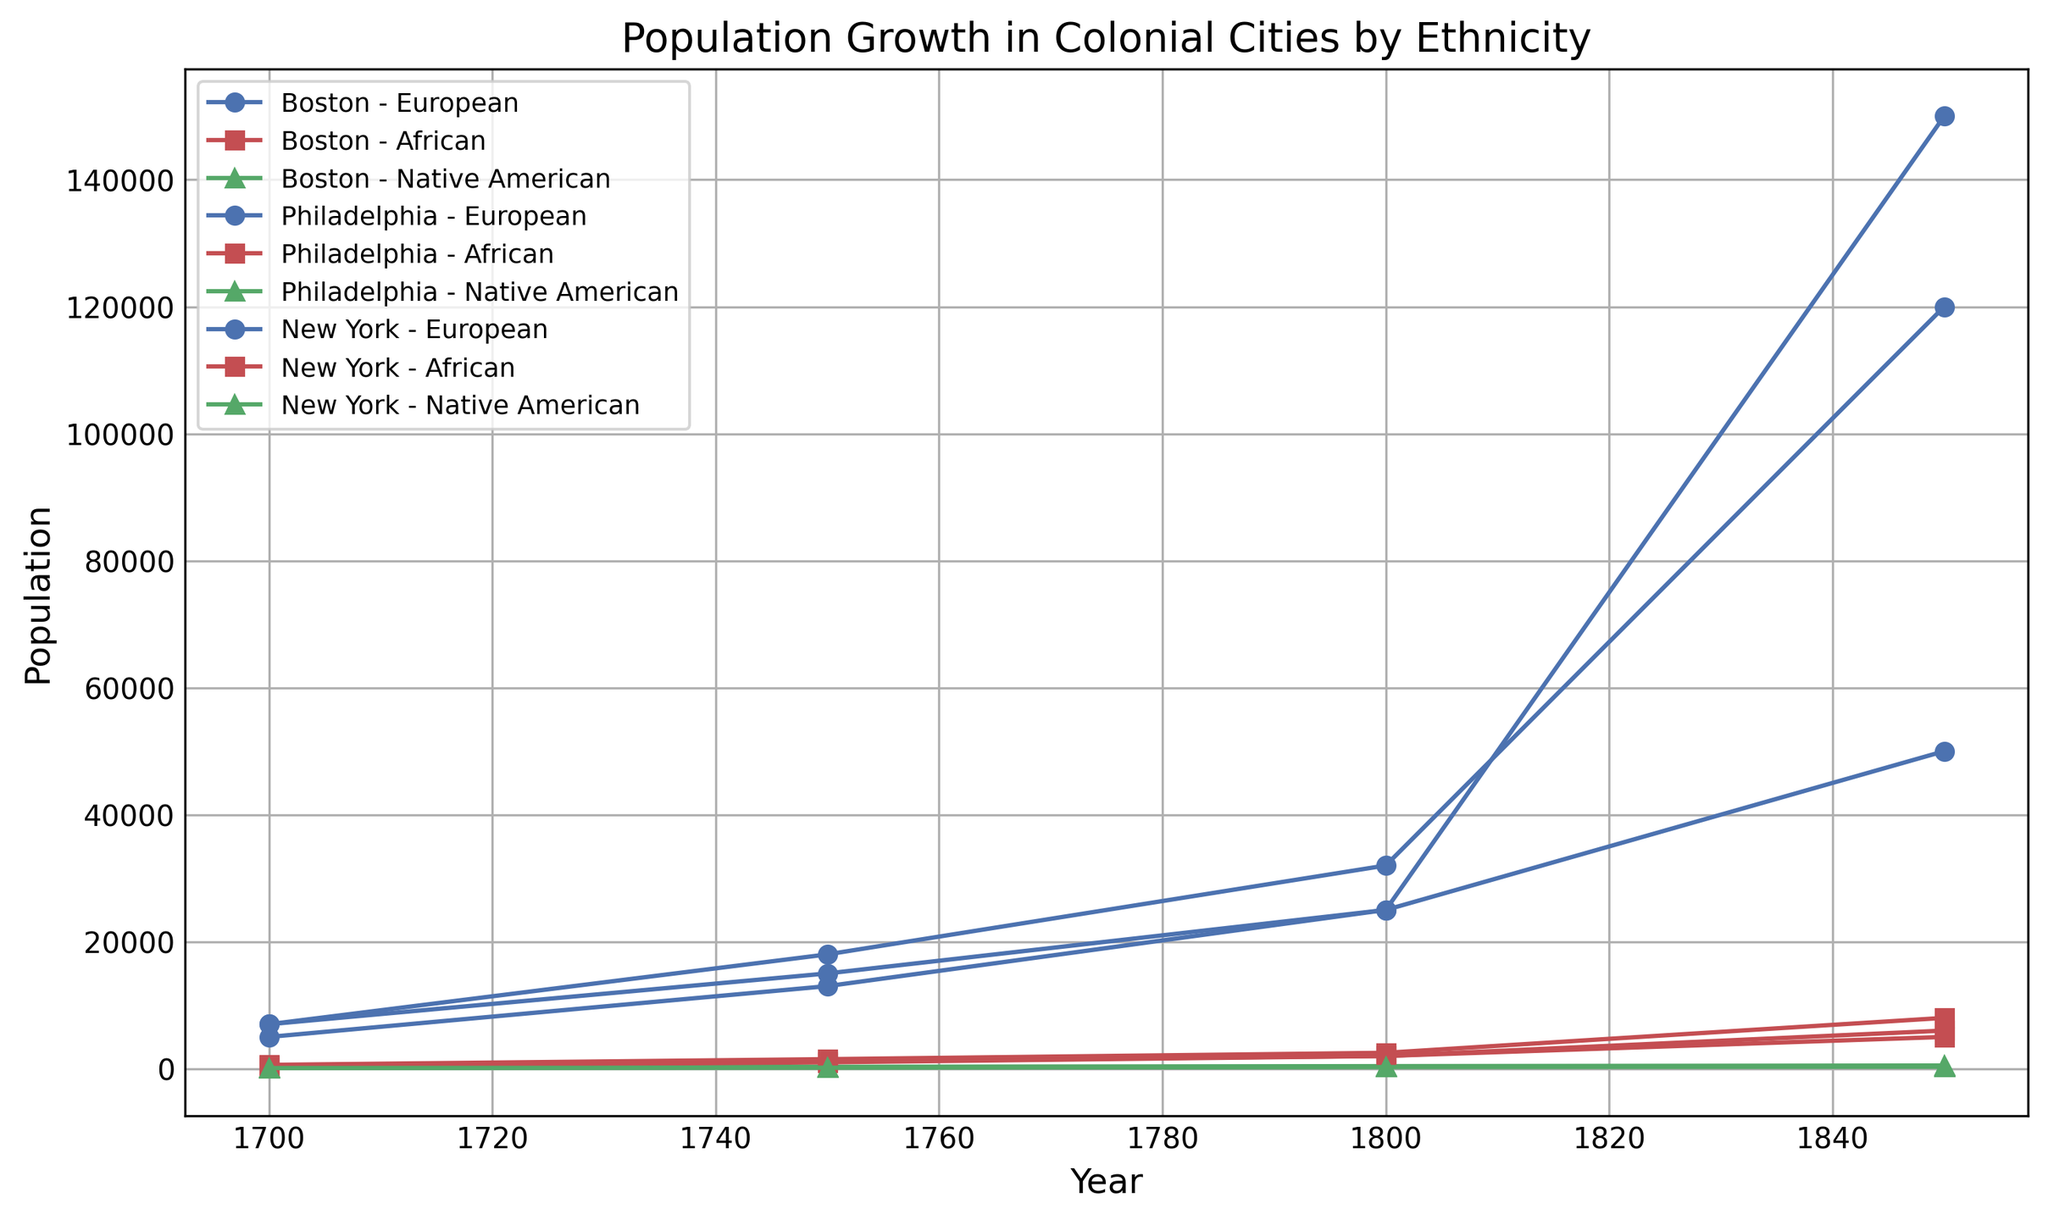What is the population difference between Europeans and Africans in Boston in 1850? From the chart, locate the population of Europeans and Africans in Boston in 1850, which are 50,000 and 5,000 respectively. The difference is obtained by subtracting the African population from the European population: 50,000 - 5,000 = 45,000.
Answer: 45,000 Which city had the largest population of Native Americans in 1750? From the figure, compare the populations of Native Americans in Boston, Philadelphia, and New York in 1750. The populations are 300, 200, and 150 respectively. Philadelphia had the largest population of Native Americans in 1750.
Answer: Philadelphia How did the European population in New York change between 1700 and 1850? Locate the European population in New York at 1700 and 1850, which are 5,000 and 150,000 respectively. The change is calculated by subtracting the 1700 value from the 1850 value: 150,000 - 5,000 = 145,000.
Answer: 145,000 Between 1700 and 1850, which city saw the greatest increase in the African population? For each city, calculate the increase in the African population from 1700 to 1850: Boston (5000 - 500 = 4500), Philadelphia (8000 - 600 = 7400), New York (6000 - 400 = 5600). Philadelphia had the greatest increase.
Answer: Philadelphia What is the average Native American population of New York from 1700 to 1850? The Native American populations of New York in the years 1700, 1750, 1800, and 1850 are 100, 150, 250, and 300 respectively. Add these values and divide by the number of data points: (100 + 150 + 250 + 300) / 4 = 200.
Answer: 200 Which ethnicity had the steepest population growth in Boston between 1700 and 1800? Compare the population growth of European, African, and Native American ethnicities in Boston between 1700 and 1800: European (25000 - 7000 = 18000), African (2000 - 500 = 1500), Native American (400 - 200 = 200). The European ethnicity had the steepest growth.
Answer: European In which city and year did the African population first reach 2000? From the figure, identify the data points where the African population is 2000: Boston (1800) and New York (1800). Both cities reached 2000 in the year 1800.
Answer: 1800 What was the combined population of Europeans in all cities in 1800? Add the populations of Europeans in Boston, Philadelphia, and New York in 1800: 25000 + 32000 + 25000 = 82000.
Answer: 82,000 Which city had the smallest overall population in 1700? Sum the population of all ethnicities in each city in 1700: Boston (7000 + 500 + 200 = 7700), Philadelphia (7000 + 600 + 150 = 7750), New York (5000 + 400 + 100 = 5500). New York had the smallest overall population.
Answer: New York 